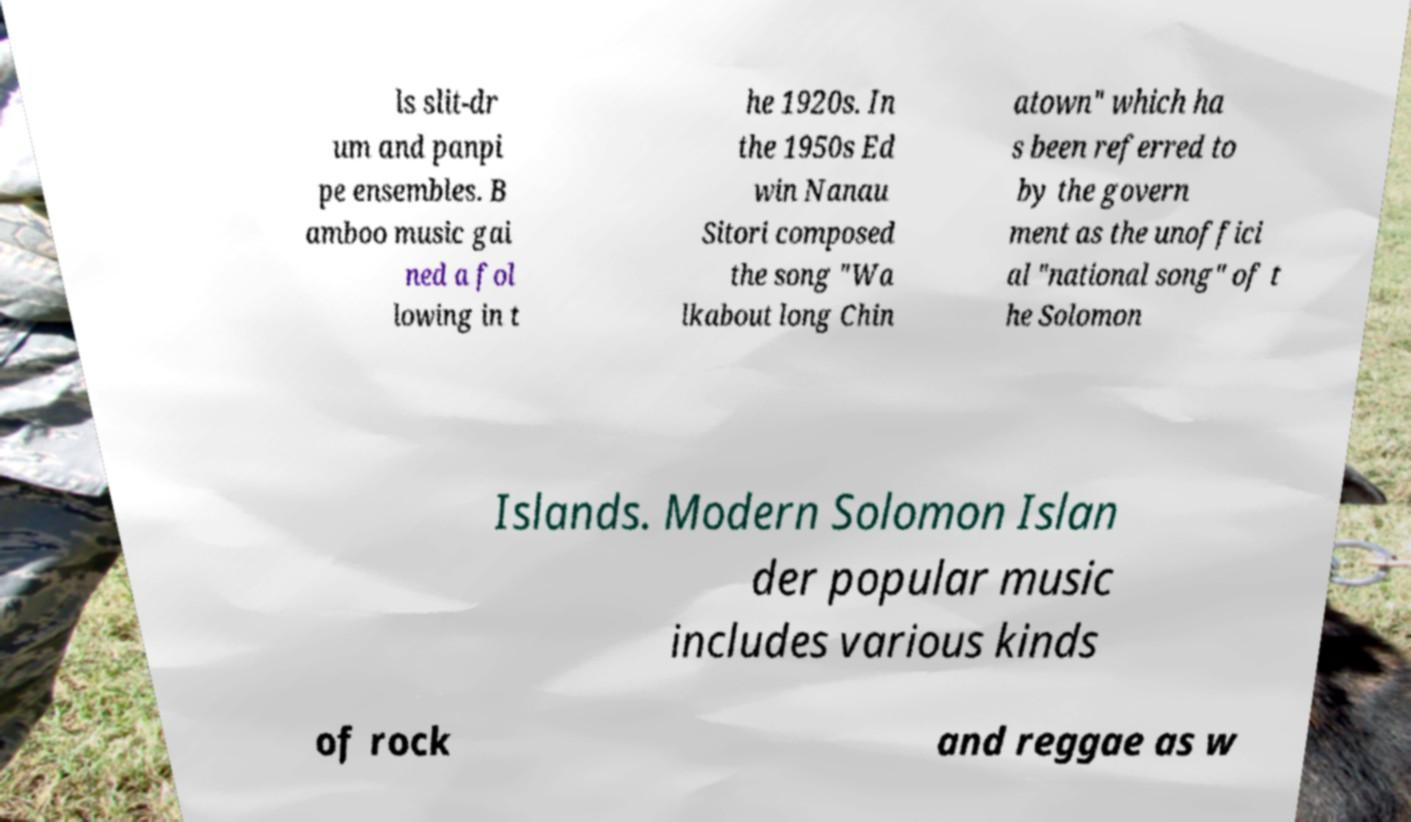Could you extract and type out the text from this image? ls slit-dr um and panpi pe ensembles. B amboo music gai ned a fol lowing in t he 1920s. In the 1950s Ed win Nanau Sitori composed the song "Wa lkabout long Chin atown" which ha s been referred to by the govern ment as the unoffici al "national song" of t he Solomon Islands. Modern Solomon Islan der popular music includes various kinds of rock and reggae as w 